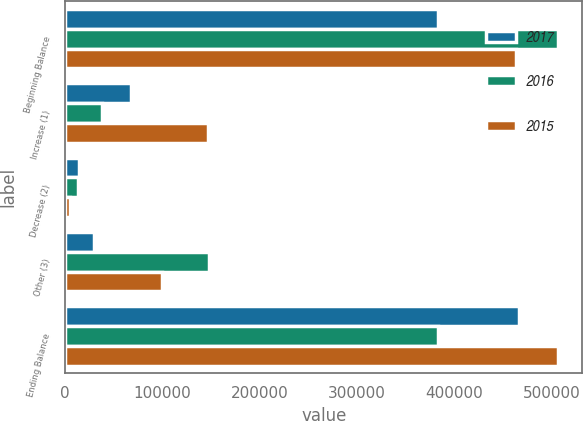Convert chart to OTSL. <chart><loc_0><loc_0><loc_500><loc_500><stacked_bar_chart><ecel><fcel>Beginning Balance<fcel>Increase (1)<fcel>Decrease (2)<fcel>Other (3)<fcel>Ending Balance<nl><fcel>2017<fcel>383221<fcel>67333<fcel>13687<fcel>29554<fcel>466421<nl><fcel>2016<fcel>506127<fcel>37221<fcel>12667<fcel>147460<fcel>383221<nl><fcel>2015<fcel>463018<fcel>146602<fcel>4315<fcel>99178<fcel>506127<nl></chart> 